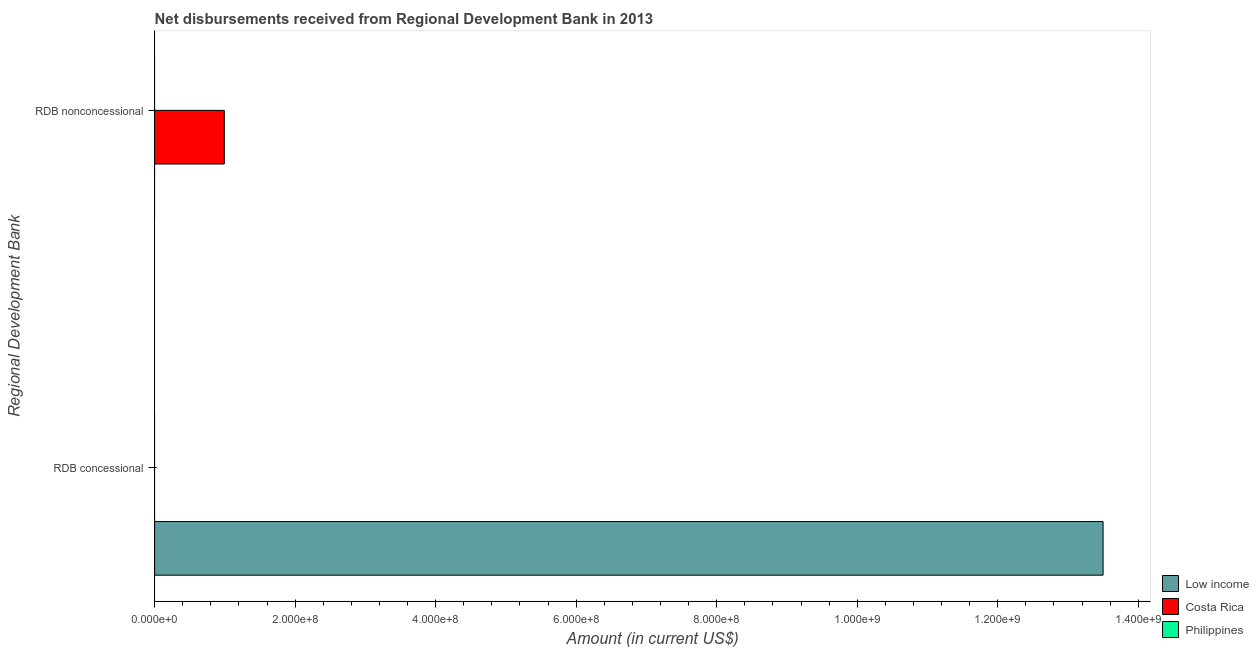How many different coloured bars are there?
Provide a short and direct response. 2. Are the number of bars per tick equal to the number of legend labels?
Offer a terse response. No. Are the number of bars on each tick of the Y-axis equal?
Your response must be concise. Yes. How many bars are there on the 2nd tick from the top?
Give a very brief answer. 1. What is the label of the 1st group of bars from the top?
Offer a terse response. RDB nonconcessional. What is the net concessional disbursements from rdb in Low income?
Give a very brief answer. 1.35e+09. Across all countries, what is the maximum net concessional disbursements from rdb?
Your answer should be very brief. 1.35e+09. What is the total net concessional disbursements from rdb in the graph?
Your response must be concise. 1.35e+09. What is the difference between the net non concessional disbursements from rdb in Philippines and the net concessional disbursements from rdb in Low income?
Offer a terse response. -1.35e+09. What is the average net non concessional disbursements from rdb per country?
Your answer should be very brief. 3.31e+07. In how many countries, is the net concessional disbursements from rdb greater than 40000000 US$?
Your response must be concise. 1. In how many countries, is the net concessional disbursements from rdb greater than the average net concessional disbursements from rdb taken over all countries?
Ensure brevity in your answer.  1. How many bars are there?
Provide a succinct answer. 2. Are all the bars in the graph horizontal?
Give a very brief answer. Yes. How many countries are there in the graph?
Make the answer very short. 3. Are the values on the major ticks of X-axis written in scientific E-notation?
Offer a terse response. Yes. Where does the legend appear in the graph?
Ensure brevity in your answer.  Bottom right. How many legend labels are there?
Your answer should be very brief. 3. What is the title of the graph?
Ensure brevity in your answer.  Net disbursements received from Regional Development Bank in 2013. Does "Ecuador" appear as one of the legend labels in the graph?
Give a very brief answer. No. What is the label or title of the Y-axis?
Make the answer very short. Regional Development Bank. What is the Amount (in current US$) of Low income in RDB concessional?
Provide a short and direct response. 1.35e+09. What is the Amount (in current US$) of Philippines in RDB concessional?
Your response must be concise. 0. What is the Amount (in current US$) in Costa Rica in RDB nonconcessional?
Your answer should be very brief. 9.92e+07. What is the Amount (in current US$) in Philippines in RDB nonconcessional?
Your answer should be compact. 0. Across all Regional Development Bank, what is the maximum Amount (in current US$) in Low income?
Your response must be concise. 1.35e+09. Across all Regional Development Bank, what is the maximum Amount (in current US$) of Costa Rica?
Offer a very short reply. 9.92e+07. Across all Regional Development Bank, what is the minimum Amount (in current US$) in Costa Rica?
Your response must be concise. 0. What is the total Amount (in current US$) of Low income in the graph?
Give a very brief answer. 1.35e+09. What is the total Amount (in current US$) in Costa Rica in the graph?
Offer a very short reply. 9.92e+07. What is the difference between the Amount (in current US$) in Low income in RDB concessional and the Amount (in current US$) in Costa Rica in RDB nonconcessional?
Your answer should be very brief. 1.25e+09. What is the average Amount (in current US$) in Low income per Regional Development Bank?
Keep it short and to the point. 6.75e+08. What is the average Amount (in current US$) of Costa Rica per Regional Development Bank?
Offer a terse response. 4.96e+07. What is the average Amount (in current US$) in Philippines per Regional Development Bank?
Offer a very short reply. 0. What is the difference between the highest and the lowest Amount (in current US$) of Low income?
Give a very brief answer. 1.35e+09. What is the difference between the highest and the lowest Amount (in current US$) of Costa Rica?
Make the answer very short. 9.92e+07. 